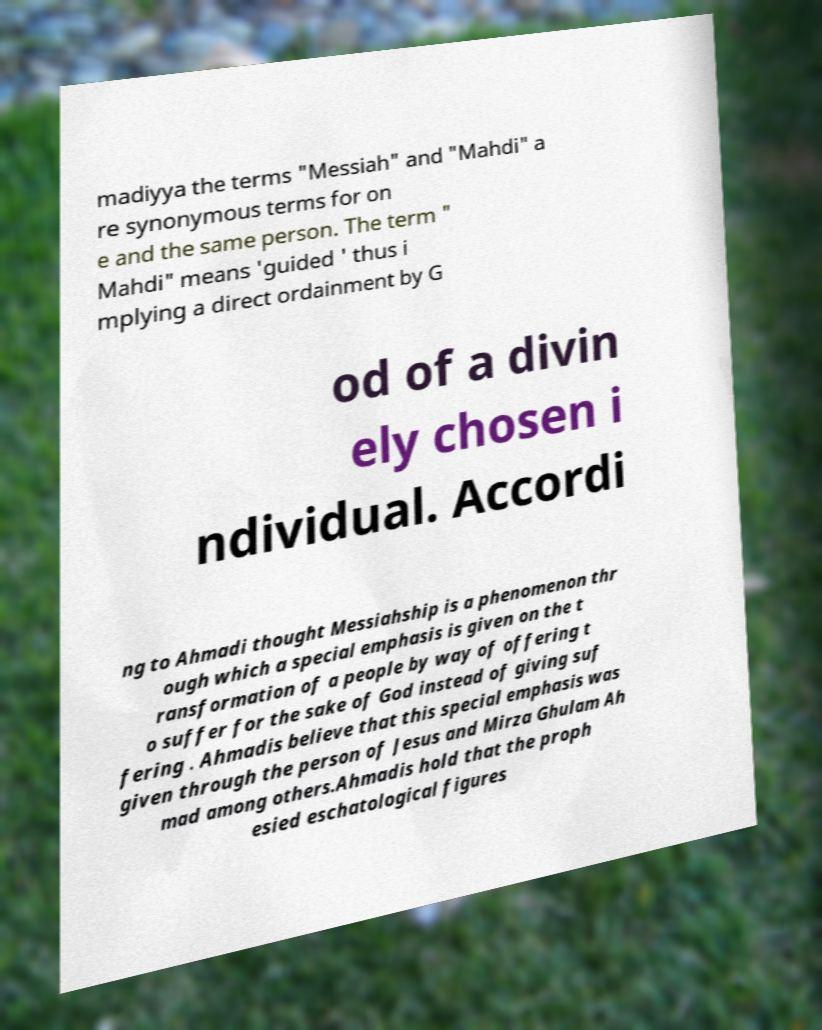Can you accurately transcribe the text from the provided image for me? madiyya the terms "Messiah" and "Mahdi" a re synonymous terms for on e and the same person. The term " Mahdi" means 'guided ' thus i mplying a direct ordainment by G od of a divin ely chosen i ndividual. Accordi ng to Ahmadi thought Messiahship is a phenomenon thr ough which a special emphasis is given on the t ransformation of a people by way of offering t o suffer for the sake of God instead of giving suf fering . Ahmadis believe that this special emphasis was given through the person of Jesus and Mirza Ghulam Ah mad among others.Ahmadis hold that the proph esied eschatological figures 